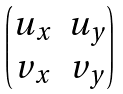<formula> <loc_0><loc_0><loc_500><loc_500>\begin{pmatrix} u _ { x } & u _ { y } \\ v _ { x } & v _ { y } \end{pmatrix}</formula> 